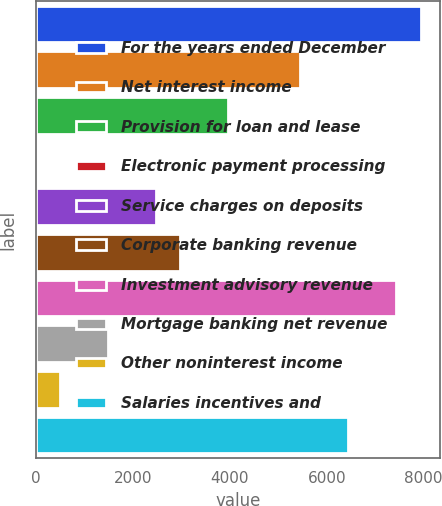Convert chart. <chart><loc_0><loc_0><loc_500><loc_500><bar_chart><fcel>For the years ended December<fcel>Net interest income<fcel>Provision for loan and lease<fcel>Electronic payment processing<fcel>Service charges on deposits<fcel>Corporate banking revenue<fcel>Investment advisory revenue<fcel>Mortgage banking net revenue<fcel>Other noninterest income<fcel>Salaries incentives and<nl><fcel>7933.8<fcel>5454.8<fcel>3967.4<fcel>1<fcel>2480<fcel>2975.8<fcel>7438<fcel>1488.4<fcel>496.8<fcel>6446.4<nl></chart> 